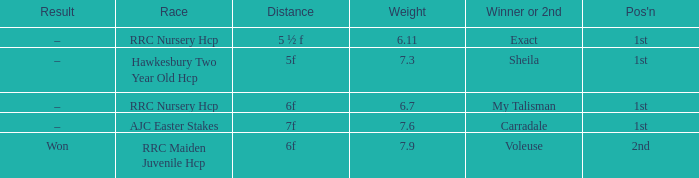What is the the name of the winner or 2nd  with a weight more than 7.3, and the result was –? Carradale. 